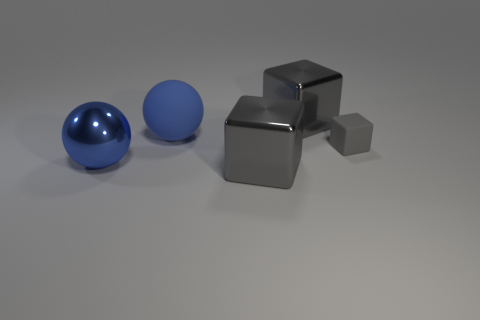There is another large ball that is the same color as the rubber sphere; what material is it?
Provide a succinct answer. Metal. What material is the cube in front of the large blue ball that is in front of the matte object on the left side of the rubber block made of?
Offer a terse response. Metal. What color is the shiny cube that is to the left of the large metal thing that is behind the small gray rubber block?
Provide a short and direct response. Gray. What number of big objects are either gray things or gray balls?
Offer a terse response. 2. What number of blue cylinders are the same material as the tiny gray cube?
Provide a succinct answer. 0. There is a blue object that is on the left side of the large blue matte thing; what is its size?
Provide a short and direct response. Large. The rubber thing that is on the left side of the shiny object behind the matte sphere is what shape?
Your answer should be compact. Sphere. There is a gray metallic object on the left side of the large cube behind the small object; what number of big things are behind it?
Provide a succinct answer. 3. Is the number of gray objects behind the small gray block less than the number of blocks?
Provide a short and direct response. Yes. Is there any other thing that is the same shape as the gray rubber thing?
Keep it short and to the point. Yes. 